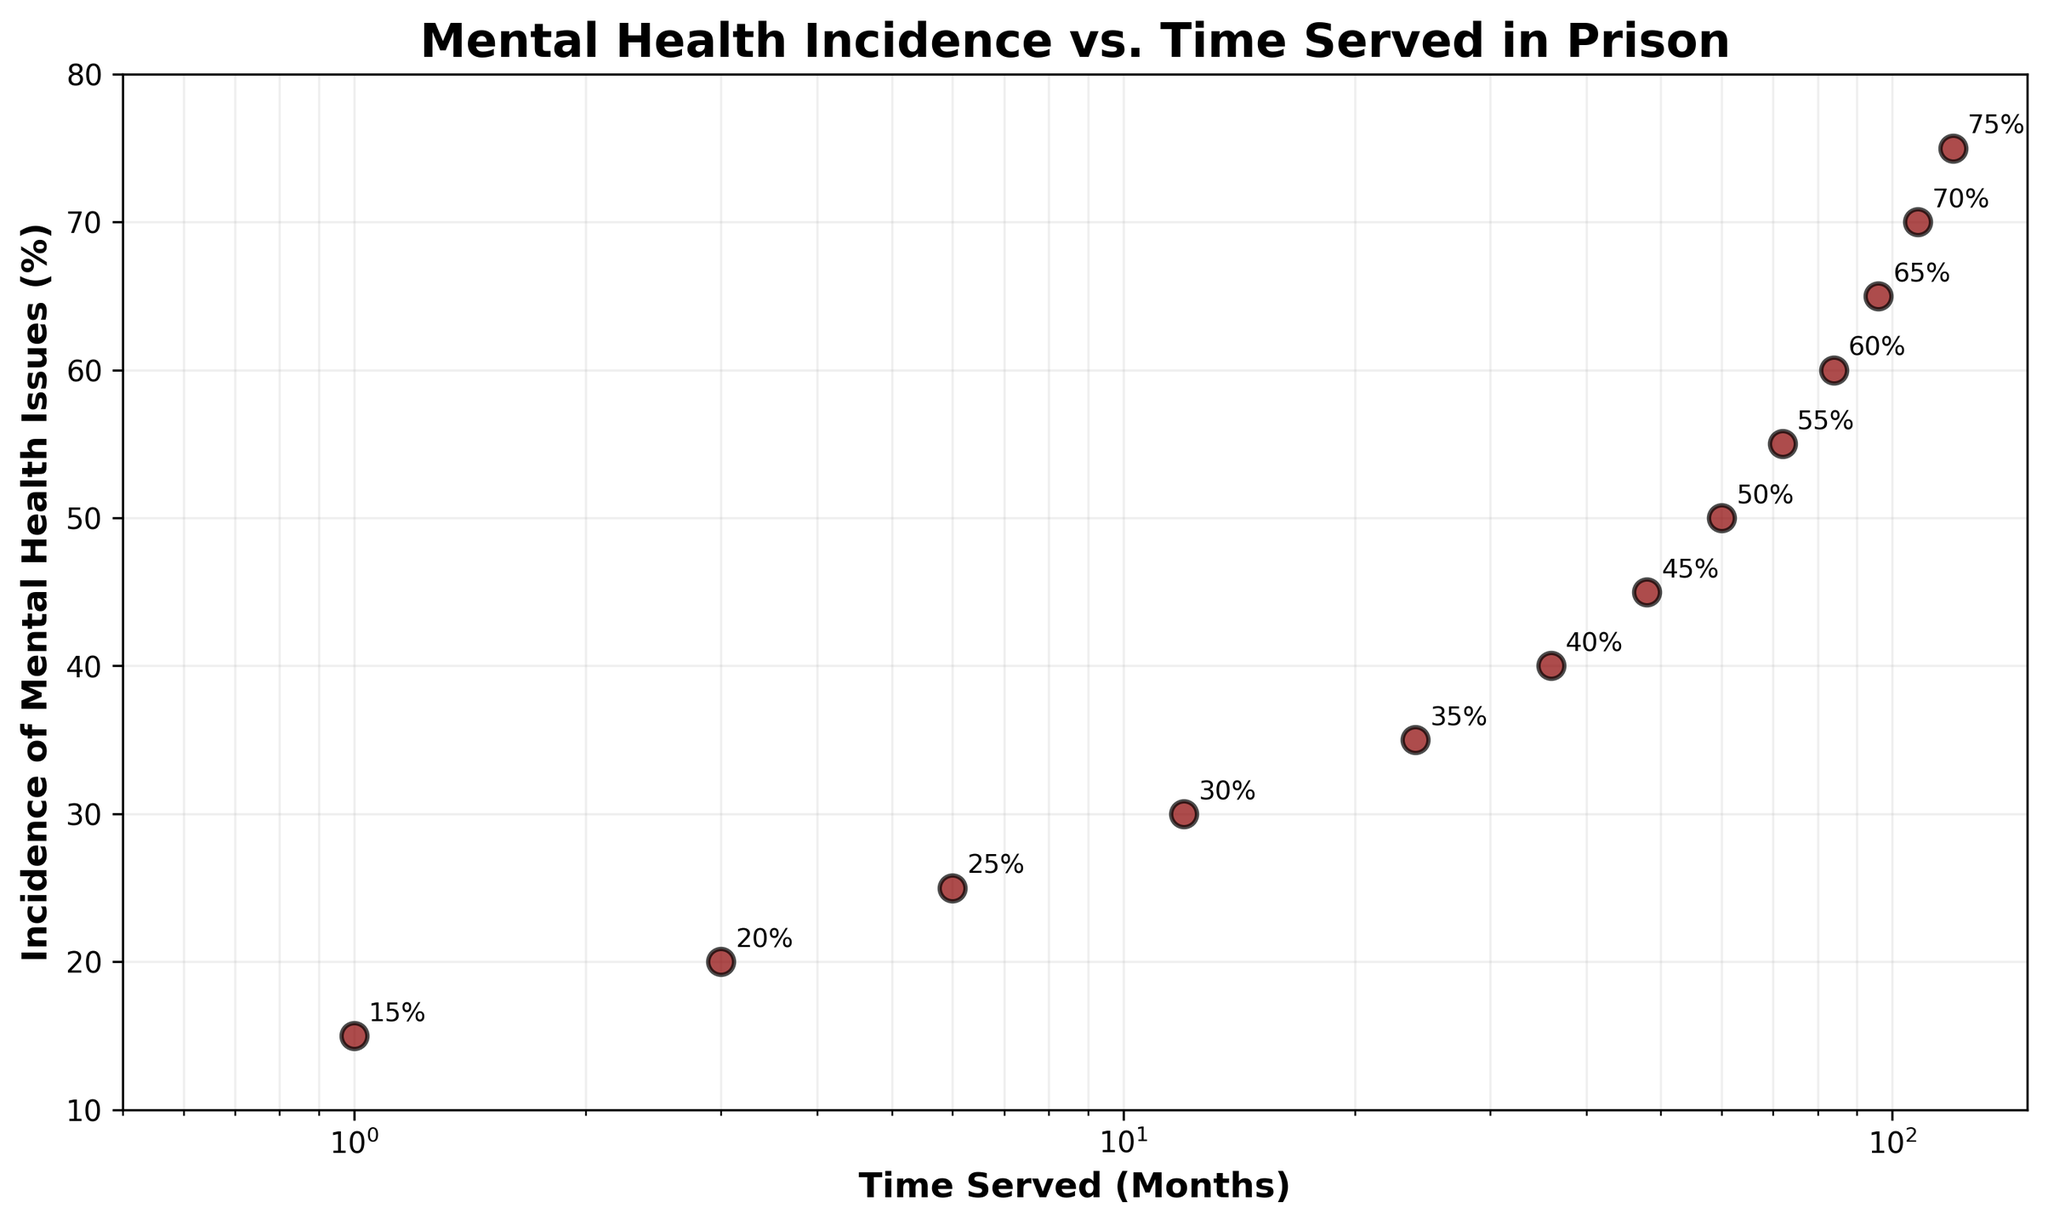What's the title of the plot? The title of the plot is usually the text displayed at the top of the figure that describes what the plot is about. In this case, it's "Mental Health Incidence vs. Time Served in Prison".
Answer: Mental Health Incidence vs. Time Served in Prison How does the incidence of mental health issues change with time served? Observing the scatter plot, the incidence of mental health issues increases as the time served increases. This is evident from the fact that the points trend upwards as you move from left to right along the x-axis.
Answer: It increases Around what percentage of mental health issues are reported by prisoners who served for 24 months? Find the data point where the x-axis value (Time_Served_Months) is 24, then observe the corresponding y-axis value (Incidence_of_Mental_Health_Issues_Percentage). At 24 months, the incidence is about 35%.
Answer: 35% What is the range of the y-axis? The y-axis represents the incidence of mental health issues as a percentage. The provided scatter plot uses a range starting from 10% up to 80%.
Answer: 10% to 80% Which time period shows the steepest increase in mental health issues? To identify the steepest increase, compare the slope between consecutive points. The largest difference seems to occur between 1 month (15%) and 3 months (20%), marking a 5% increase over a short time span.
Answer: Between 1 and 3 months Describe the grid style used in the plot. The plot uses a grid with lines that are both horizontal and vertical. These lines are light ("-"), transparent (alpha=0.2), and the grid is set to be below other plot elements. This makes the data points more readable.
Answer: Light, transparent, and below the plot elements What can you infer about mental health issues in prisoners from 1 month to 120 months? From 1 month to 120 months, the scatter plot shows an increasing trend in the incidence of mental health issues among prisoners. This suggests that the longer the time served, the higher the likelihood of mental health issues.
Answer: Longer time served correlates with higher mental health issues What trend is visible over the log-scaled x-axis? Log scale compresses the wide range of time served into a more readable format. The trend shows a steady increase of mental health issues, indicating an exponential relationship between time served and mental health issues.
Answer: Exponential growth trend Compare the incidence of mental health issues at 36 months and 72 months. At 36 months, the incidence is 40%, while at 72 months, it is 55%. This indicates a 15% increase over the 36-month difference.
Answer: 40% at 36 months and 55% at 72 months What is the approximate incidence percentage at 108 months, and how does it compare to 60 months? At 108 months, the incidence is approximately 70%, while at 60 months, it is around 50%. This shows an increase of 20% over that period.
Answer: 70% at 108 months and 50% at 60 months 